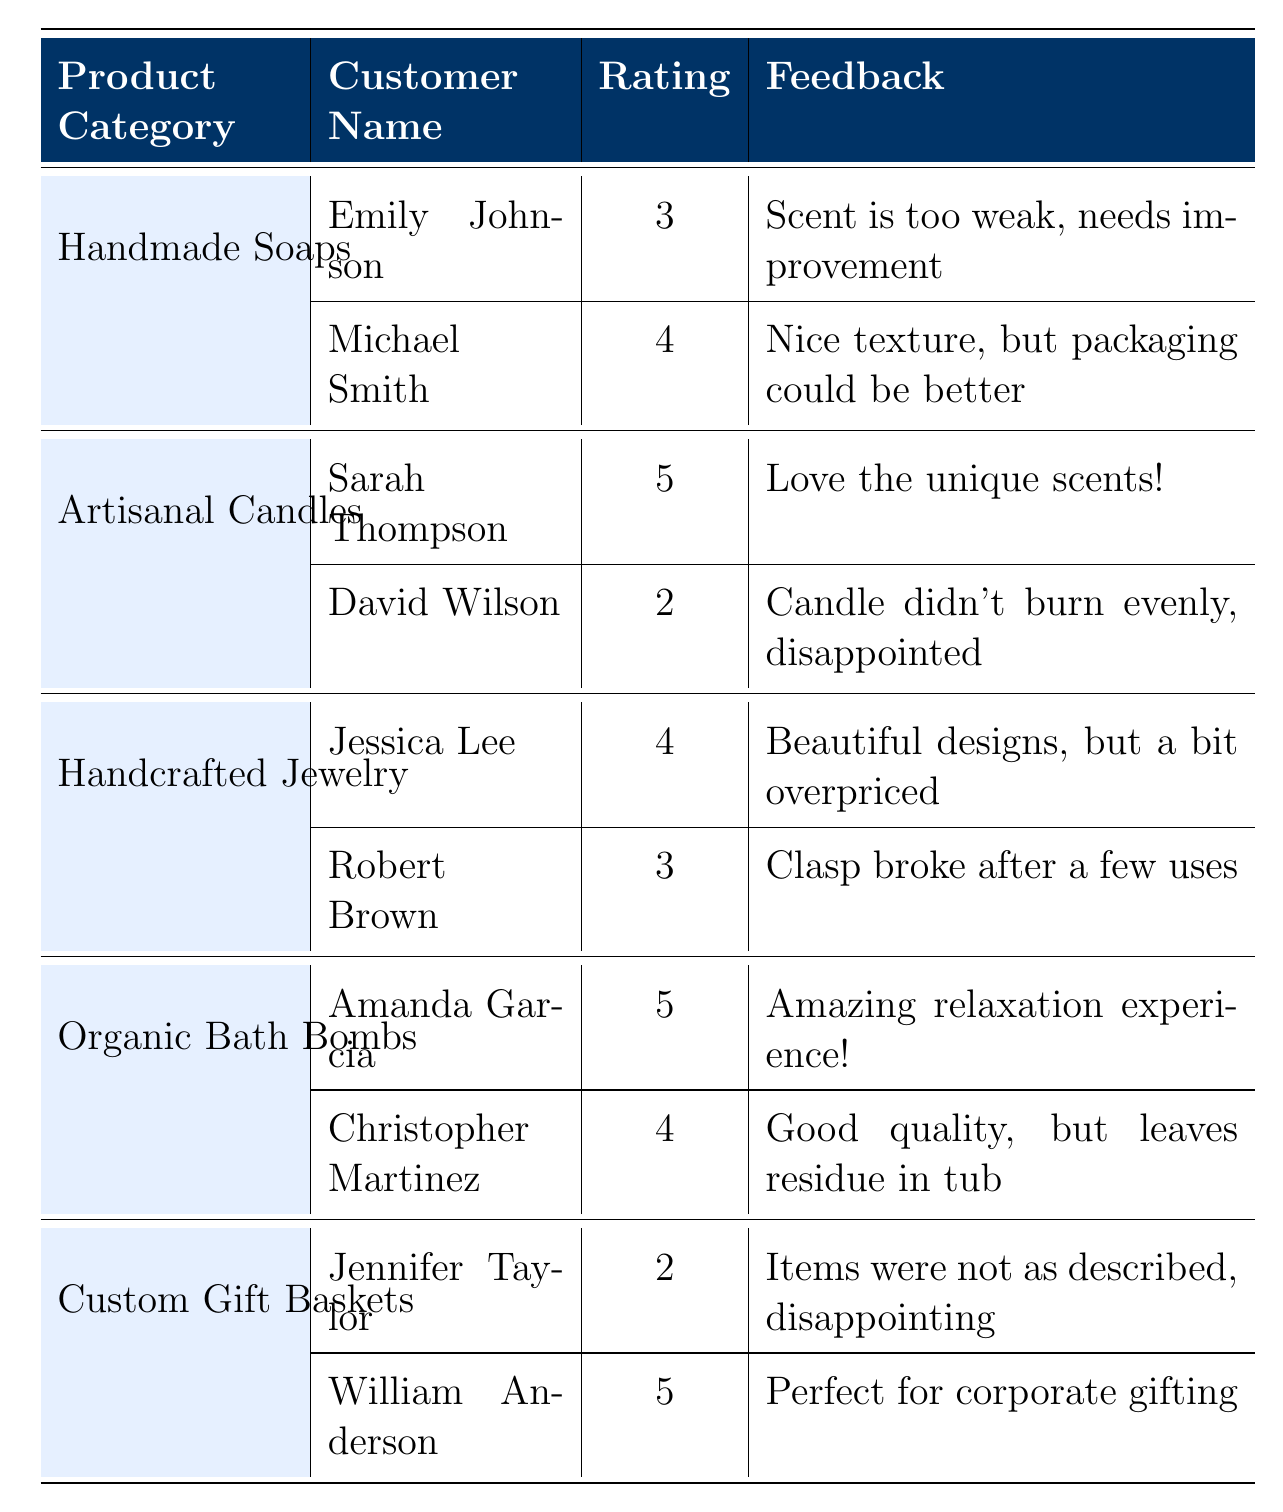What is the highest rating received among the product categories? The highest rating shown in the table is 5, which is given for the "Artisanal Candles" by Sarah Thompson and "Organic Bath Bombs" by Amanda Garcia.
Answer: 5 Who gave a 2-star rating in the "Custom Gift Baskets" category? According to the table, Jennifer Taylor gave a 2-star rating in the "Custom Gift Baskets" category.
Answer: Jennifer Taylor What is the average rating for the "Handcrafted Jewelry" category? The ratings for "Handcrafted Jewelry" are 4 and 3. To find the average, we sum the ratings (4 + 3) = 7 and divide by the number of ratings (2), which gives us 7/2 = 3.5.
Answer: 3.5 Did Sarah Thompson give a higher rating than David Wilson for "Artisanal Candles"? Yes, Sarah Thompson gave a rating of 5 while David Wilson gave a rating of 2, indicating that Sarah's rating is higher than David's.
Answer: Yes What is the total number of ratings for the "Organic Bath Bombs" category? The "Organic Bath Bombs" category has two ratings: 5 and 4. Thus, the total number of ratings is 2.
Answer: 2 What percentage of customers rated "Handmade Soaps" 4 stars or higher? There are two customers for "Handmade Soaps": Emily Johnson rated 3 and Michael Smith rated 4. Only Michael's rating is 4 or higher. To calculate the percentage: (1/2) * 100 = 50%.
Answer: 50% Is there any customer who rated the "Artisanal Candles" category with a score of 3 or higher? Yes, Sarah Thompson rated "Artisanal Candles" with a score of 5 and Michael Smith rated it with a score of 4, indicating there are customers who rated it 3 or higher.
Answer: Yes Which product category has the most varied ratings? The "Artisanal Candles" category has ratings of 5 and 2, leading to the highest difference of 3. Other categories have lesser differences (max 2), indicating it is the most varied.
Answer: Artisanal Candles How many customers left feedback indicating they were disappointed with the products? Two customers left disappointed feedback: David Wilson for "Artisanal Candles" and Jennifer Taylor for "Custom Gift Baskets." Thus, the count is 2.
Answer: 2 What feedback did the highest-rated product category receive? The highest-rated product category, "Artisanal Candles," received positive feedback ("Love the unique scents!") from Sarah Thompson and negative feedback ("Candle didn't burn evenly, disappointed") from David Wilson.
Answer: Mixed feedback 